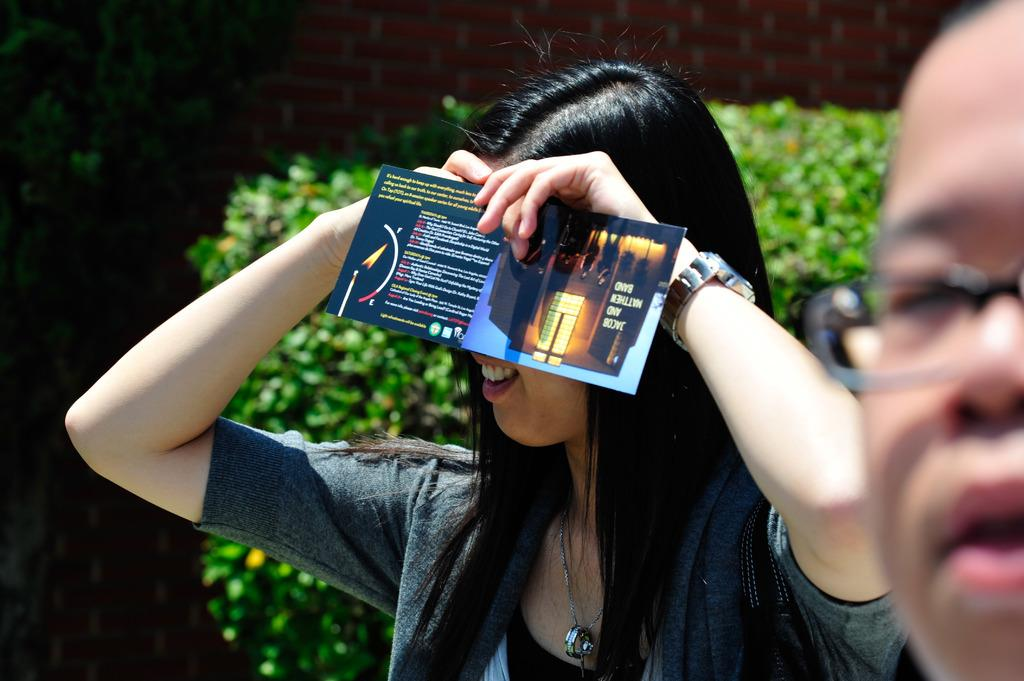Who is present in the image? There is a woman in the image. What is the woman holding? The woman is holding a paper. What accessory is the woman wearing? The woman is wearing a watch. What can be seen in the background of the image? There are plants visible in the background of the image. Who else is present in the image? There is a person wearing spectacles on the right side of the image. What type of dinner is being served in the image? There is no dinner present in the image; it features a woman holding a paper and a person wearing spectacles. What role does the minister play in the image? There is no minister present in the image. 